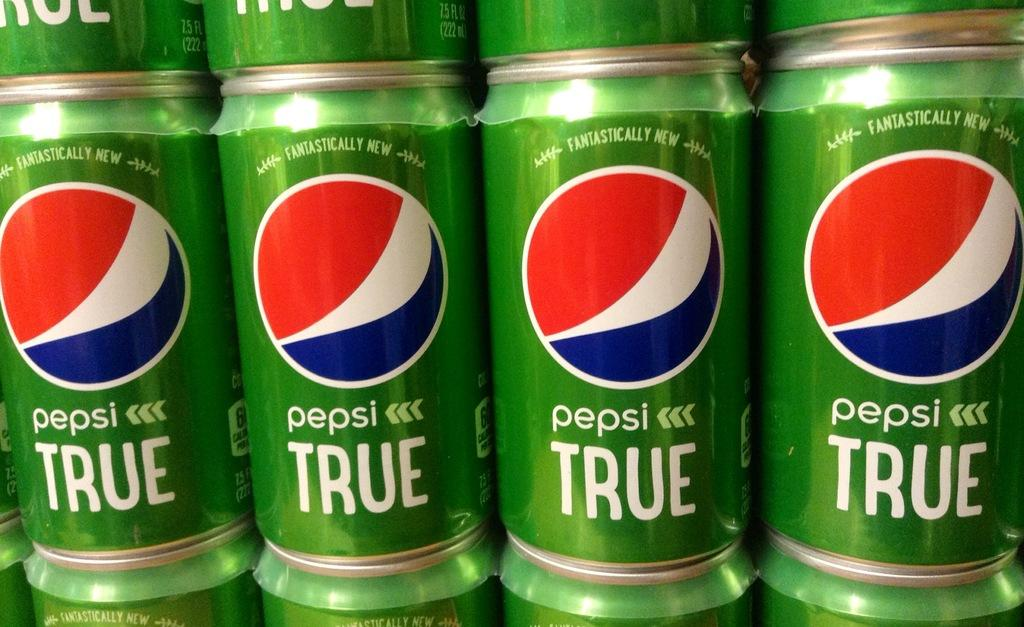<image>
Describe the image concisely. Several green cans of Pepsi TRUE are stack on top of each other. 